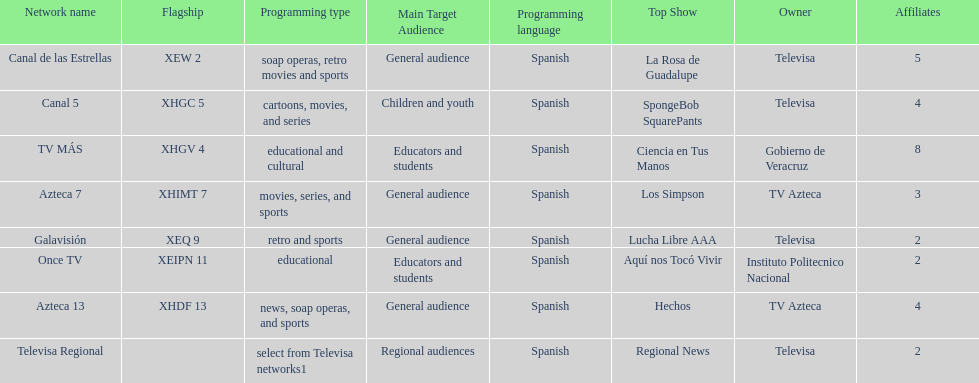What is the number of affiliates of canal de las estrellas. 5. 